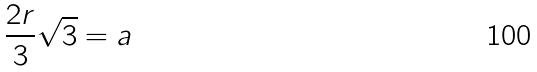Convert formula to latex. <formula><loc_0><loc_0><loc_500><loc_500>\frac { 2 r } { 3 } \sqrt { 3 } = a</formula> 